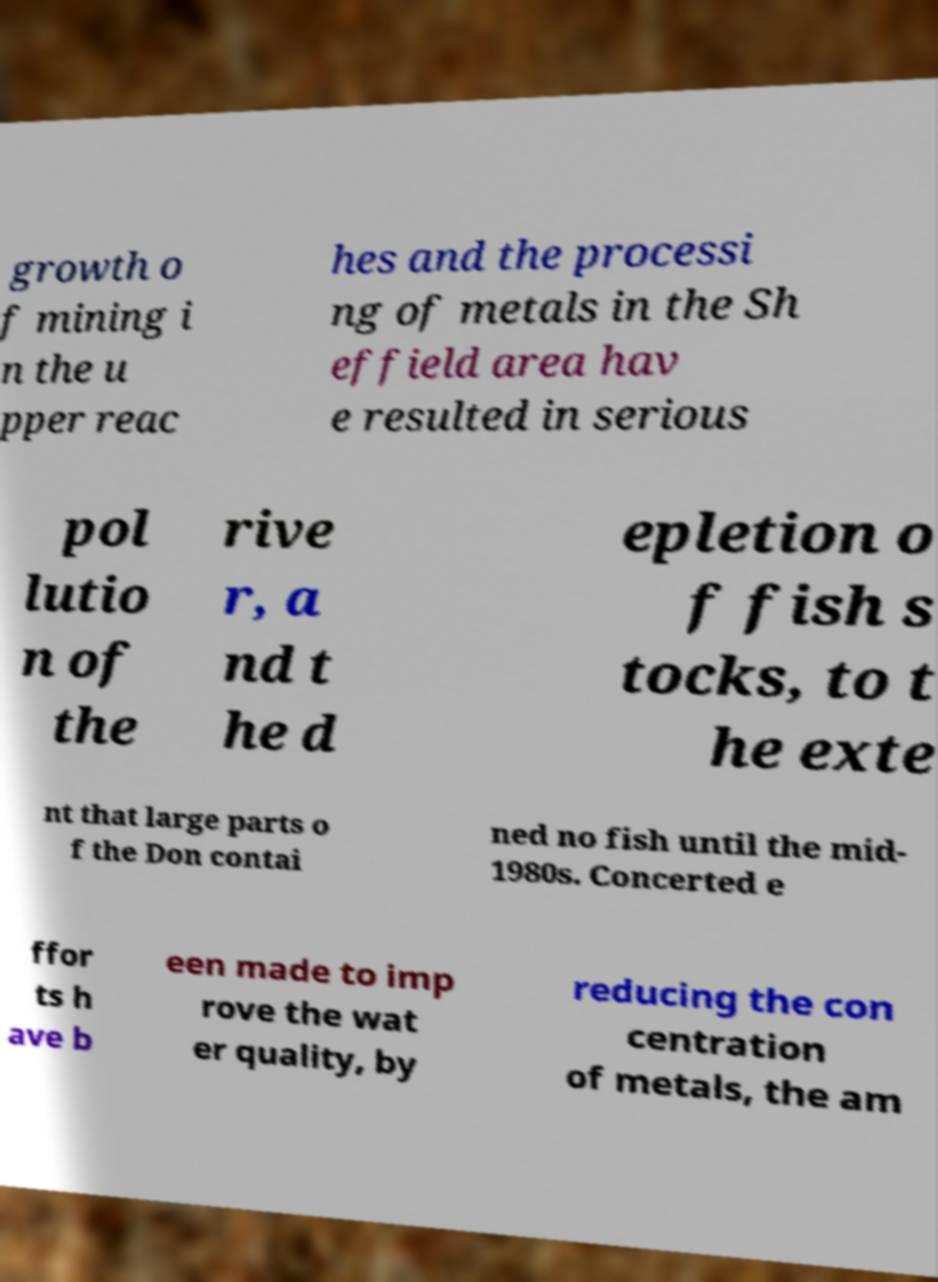Can you accurately transcribe the text from the provided image for me? growth o f mining i n the u pper reac hes and the processi ng of metals in the Sh effield area hav e resulted in serious pol lutio n of the rive r, a nd t he d epletion o f fish s tocks, to t he exte nt that large parts o f the Don contai ned no fish until the mid- 1980s. Concerted e ffor ts h ave b een made to imp rove the wat er quality, by reducing the con centration of metals, the am 